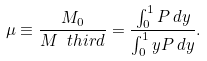Convert formula to latex. <formula><loc_0><loc_0><loc_500><loc_500>\mu \equiv \frac { M _ { 0 } } { M _ { \ } t h i r d } = \frac { \int _ { 0 } ^ { 1 } P \, d y } { \int _ { 0 } ^ { 1 } y P \, d y } .</formula> 